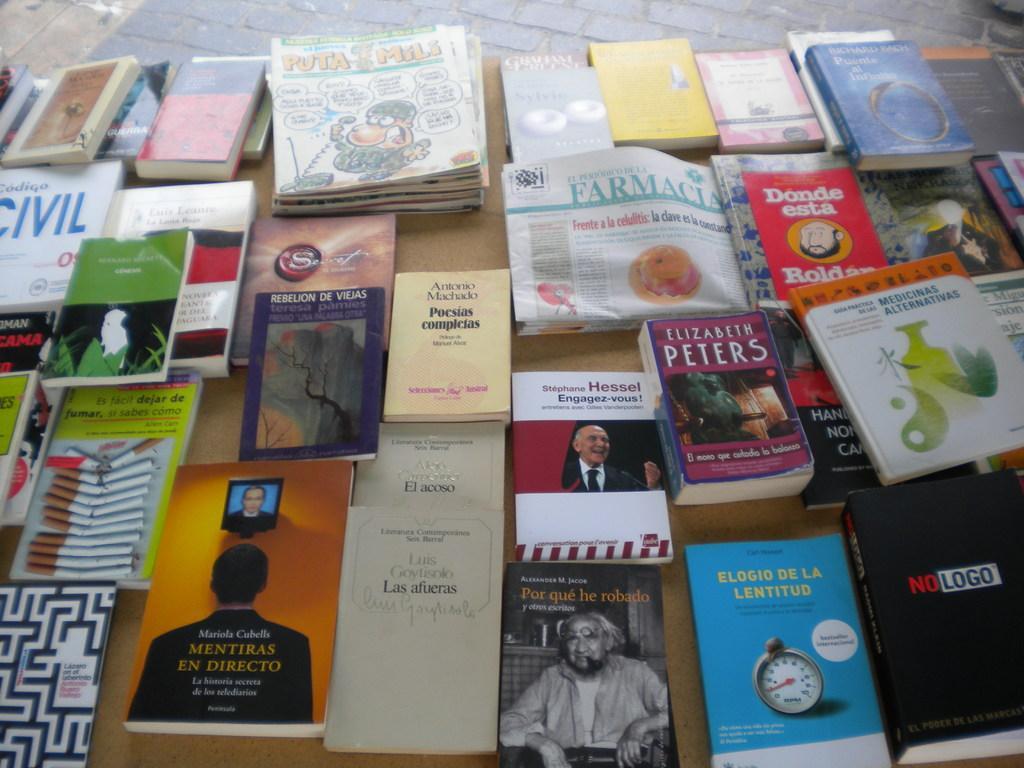Can you describe this image briefly? In the foreground of the picture we can see books and newspapers on a table. At the top it is floor. 